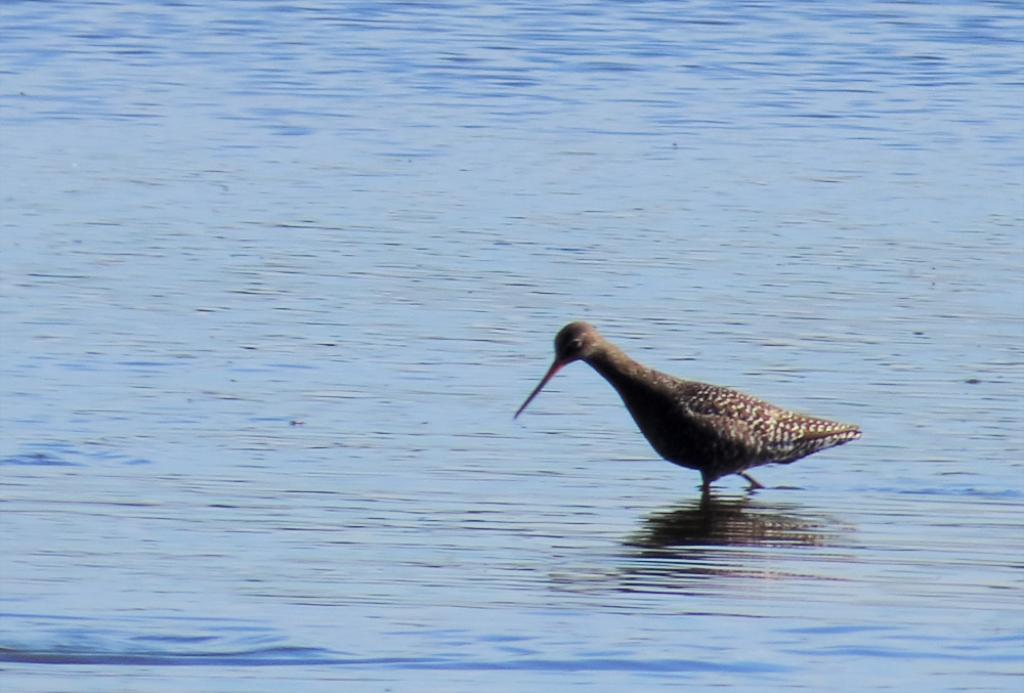What type of animal is present in the image? There is a bird in the image. What is the bird doing in the image? The bird is walking on a water body. What type of dress is the bird wearing in the image? There is no dress present in the image, as birds do not wear clothing. 